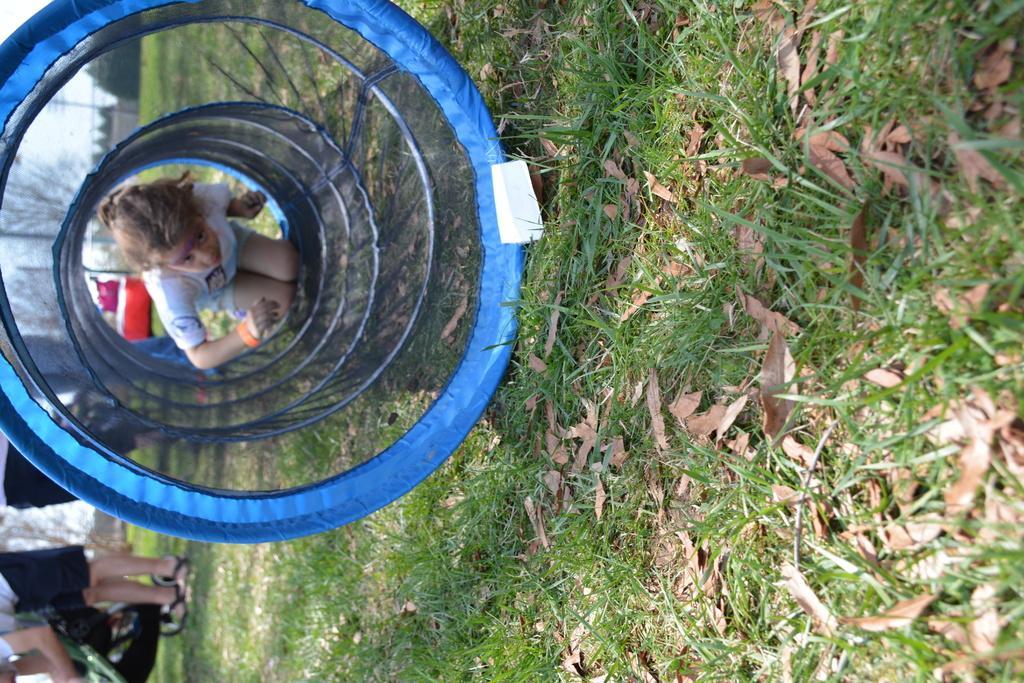Please provide a concise description of this image. In the image in the center we can see grass,dry leaves and one round shape object,in which we can see one girl trying to enter in it. In the background we can see the sky,clouds,trees and one person standing and holding some objects. 